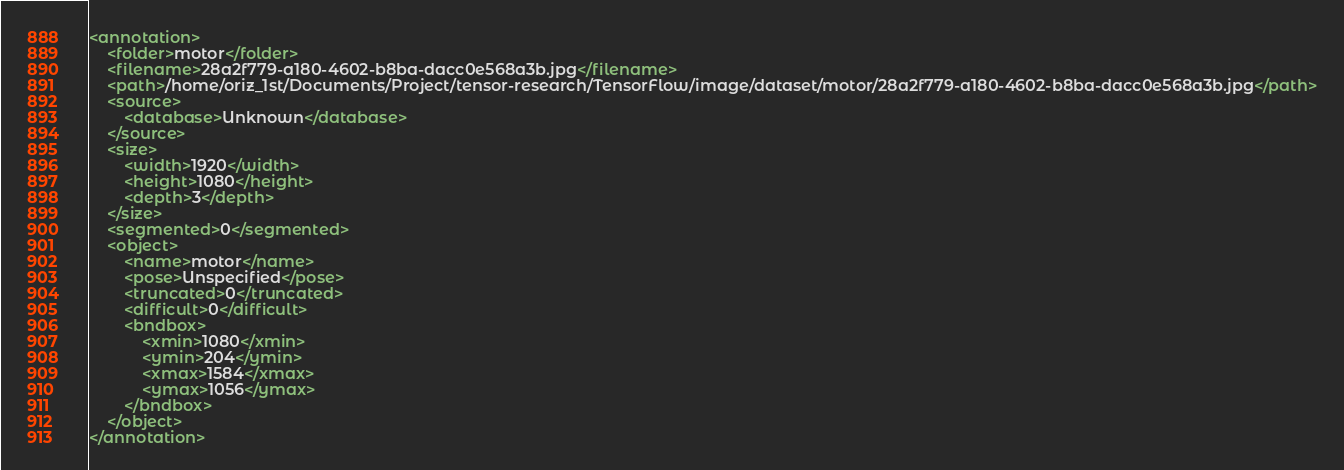<code> <loc_0><loc_0><loc_500><loc_500><_XML_><annotation>
	<folder>motor</folder>
	<filename>28a2f779-a180-4602-b8ba-dacc0e568a3b.jpg</filename>
	<path>/home/oriz_1st/Documents/Project/tensor-research/TensorFlow/image/dataset/motor/28a2f779-a180-4602-b8ba-dacc0e568a3b.jpg</path>
	<source>
		<database>Unknown</database>
	</source>
	<size>
		<width>1920</width>
		<height>1080</height>
		<depth>3</depth>
	</size>
	<segmented>0</segmented>
	<object>
		<name>motor</name>
		<pose>Unspecified</pose>
		<truncated>0</truncated>
		<difficult>0</difficult>
		<bndbox>
			<xmin>1080</xmin>
			<ymin>204</ymin>
			<xmax>1584</xmax>
			<ymax>1056</ymax>
		</bndbox>
	</object>
</annotation>
</code> 